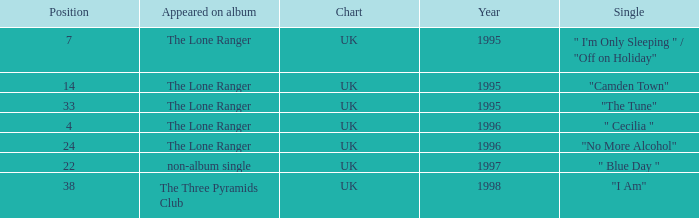When the position is less than 7, what is the appeared on album? The Lone Ranger. 